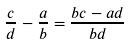<formula> <loc_0><loc_0><loc_500><loc_500>\frac { c } { d } - \frac { a } { b } = \frac { b c - a d } { b d }</formula> 